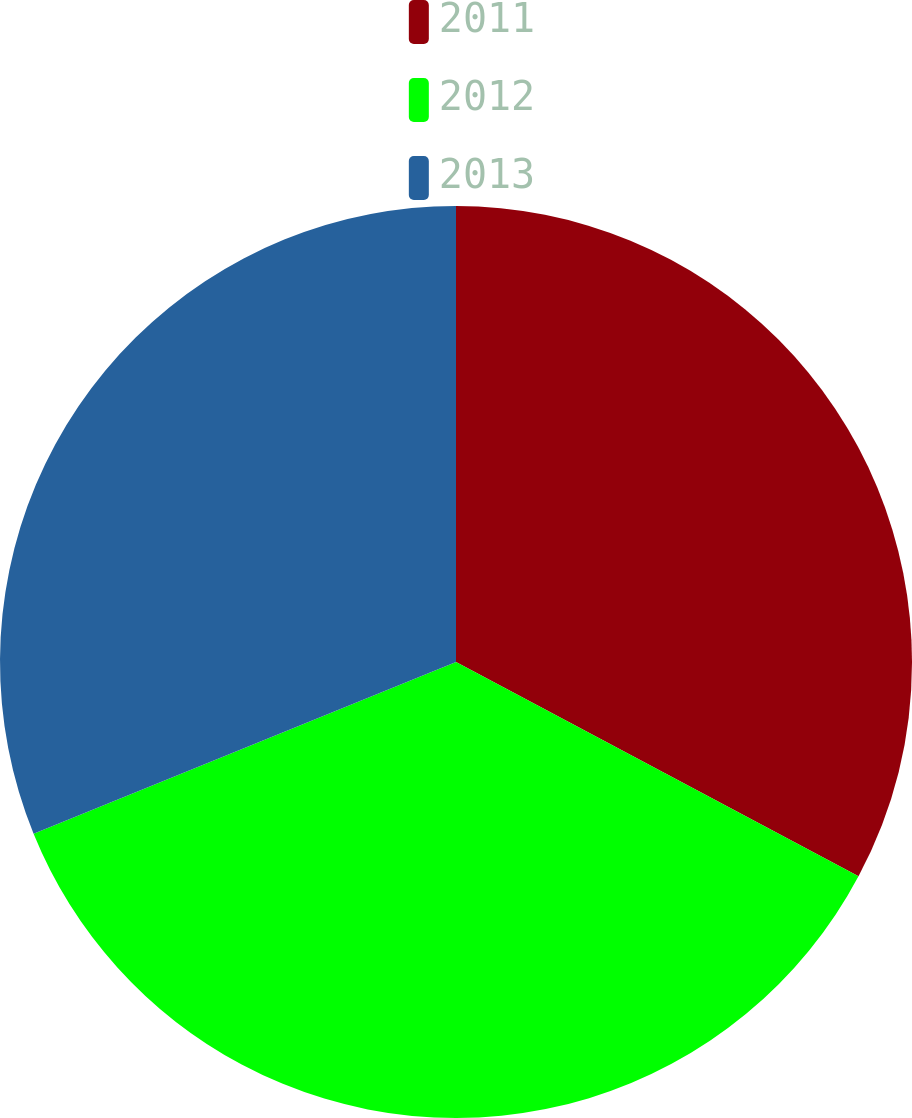Convert chart. <chart><loc_0><loc_0><loc_500><loc_500><pie_chart><fcel>2011<fcel>2012<fcel>2013<nl><fcel>32.79%<fcel>36.07%<fcel>31.15%<nl></chart> 